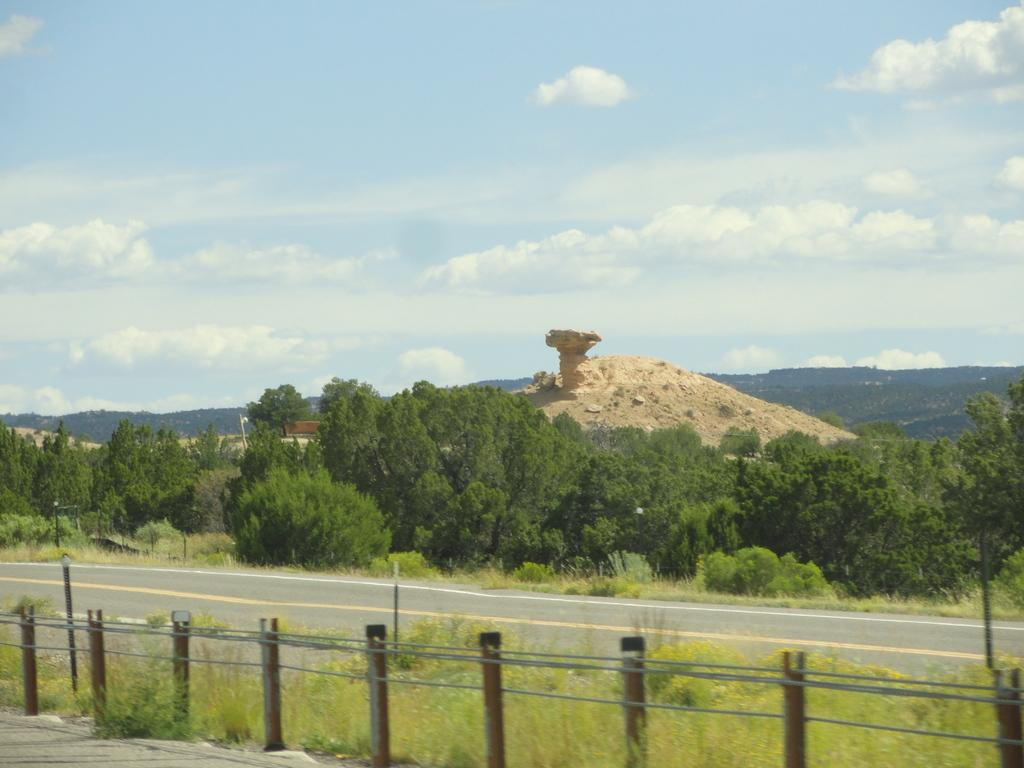What type of barrier can be seen in the image? There is a fence in the image. What type of pathway is present in the image? There is a road in the image. What type of vegetation is visible in the image? There are plants and trees in the image. What type of natural formation is visible in the image? There are mountains in the image. What type of ground is visible in the image? Soil is visible in the image. What type of objects are present in the image? There are objects in the image. What is visible in the background of the image? The sky is visible in the background of the image. What type of atmospheric phenomenon can be seen in the sky? Clouds are present in the sky. What type of hose can be seen spraying water on the plants in the image? There is no hose present in the image. What type of smell can be detected from the plants in the image? The image does not provide any information about the smell of the plants. What type of emotion can be seen on the faces of the objects in the image? The image does not depict faces or emotions, as it features inanimate objects. 